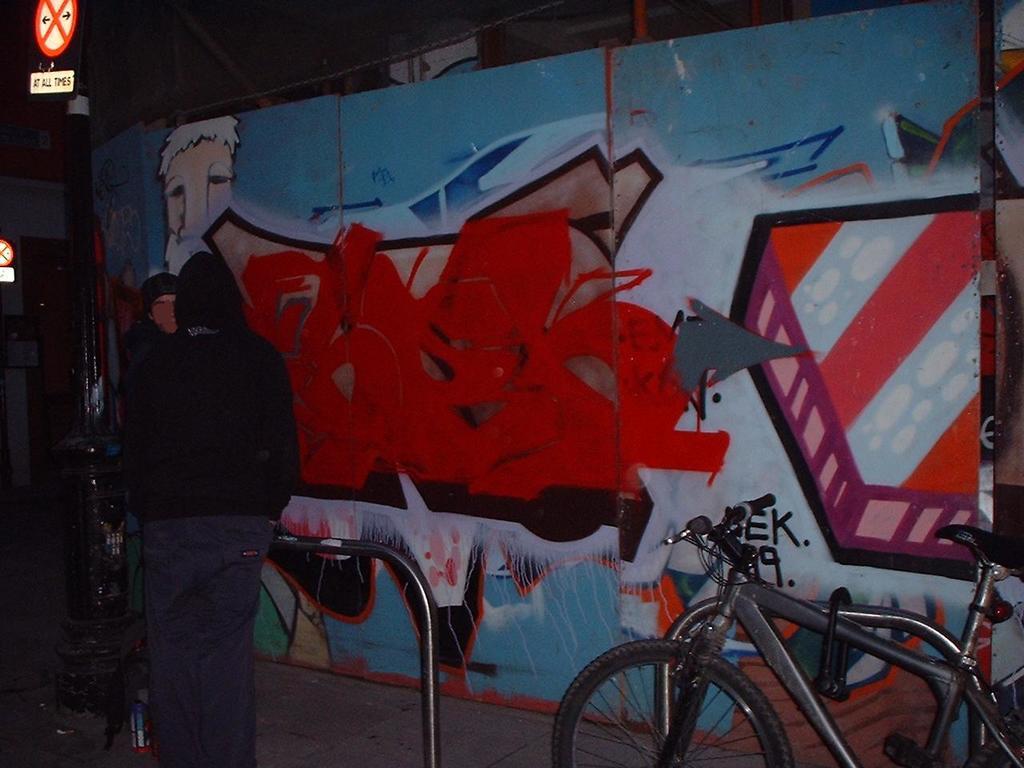Please provide a concise description of this image. In this image I can see a person standing. I can see a bicycle and sign boards and poles. The wall is in colorful. 